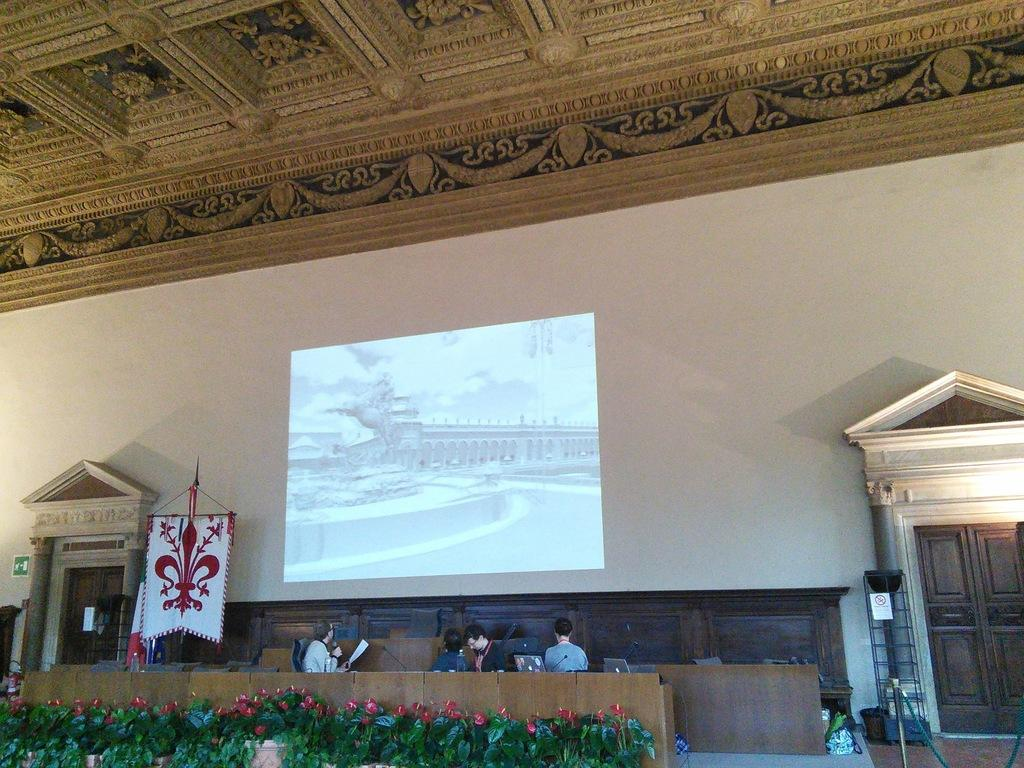What types of living organisms can be seen in the image? Plants and flowers are visible in the image. What electronic devices can be seen in the image? Microphones and laptops are visible in the image. What type of containers are present in the image? Bottles are present in the image. What architectural features can be seen in the image? Doors are visible in the image. What type of decorative items are present in the image? Flags are visible in the image. How many people are in the image? There are four people in the image. What is on the wall in the image? There is a screen on the wall in the image. What part of a building can be seen in the image? There is a ceiling visible in the image. What additional objects can be seen in the image? Some objects are present in the image. What type of fruit is being used as a decoration in the image? There is no fruit being used as a decoration in the image. What type of clothing is being worn by the people in the image? The provided facts do not mention any clothing worn by the people in the image. What type of room is depicted in the image? The provided facts do not specify the type of room or hall in the image. 